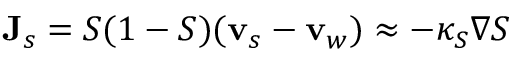<formula> <loc_0><loc_0><loc_500><loc_500>{ J } _ { s } = S ( 1 - S ) ( { v } _ { s } - { v } _ { w } ) \approx - \kappa _ { S } \nabla S</formula> 